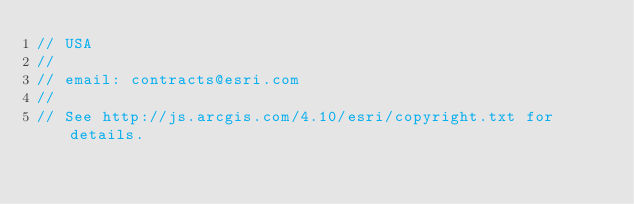<code> <loc_0><loc_0><loc_500><loc_500><_JavaScript_>// USA
//
// email: contracts@esri.com
//
// See http://js.arcgis.com/4.10/esri/copyright.txt for details.
</code> 